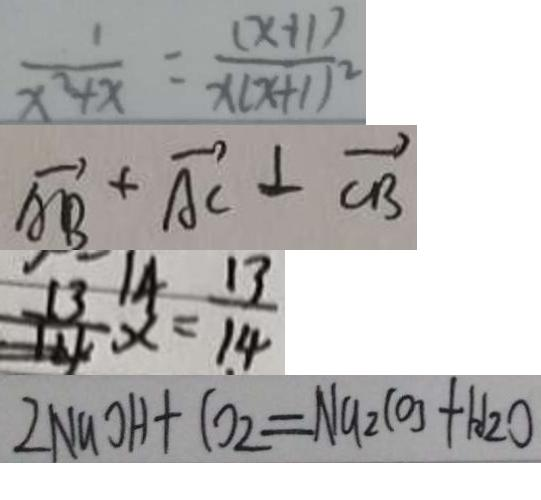<formula> <loc_0><loc_0><loc_500><loc_500>\frac { 1 } { x ^ { 2 } + x } = \frac { ( x + 1 ) } { x ( x + 1 ) ^ { 2 } } 
 \overrightarrow { A B } + \overrightarrow { A C } \bot \overrightarrow { C B } 
 x = \frac { 1 3 } { 1 4 } 
 2 N a O H + C O _ { 2 } = N a _ { 2 } C O _ { 3 } + H _ { 2 } O</formula> 